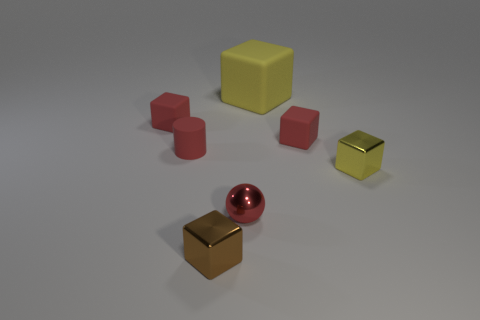Are there any other things that have the same shape as the small red shiny object?
Your answer should be compact. No. There is a tiny cylinder that is the same material as the big yellow object; what color is it?
Provide a succinct answer. Red. What shape is the yellow rubber object?
Make the answer very short. Cube. What number of things have the same color as the big block?
Your response must be concise. 1. What is the shape of the yellow thing that is the same size as the red cylinder?
Keep it short and to the point. Cube. Are there any brown metallic blocks of the same size as the yellow matte object?
Your answer should be compact. No. What is the material of the yellow thing that is the same size as the brown cube?
Offer a very short reply. Metal. What is the size of the red rubber thing on the right side of the big block that is on the right side of the ball?
Give a very brief answer. Small. There is a shiny object in front of the metal sphere; is its size the same as the small red metal thing?
Make the answer very short. Yes. Are there more blocks to the left of the small brown metallic cube than small brown metallic things behind the red ball?
Provide a short and direct response. Yes. 